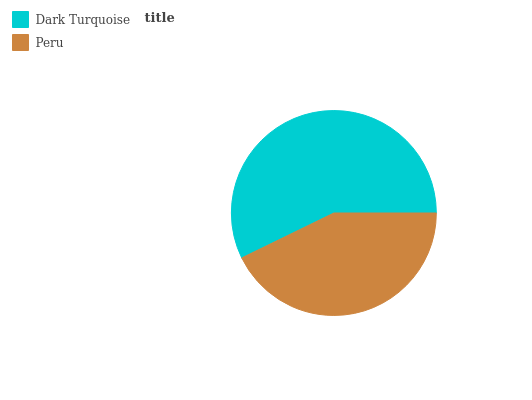Is Peru the minimum?
Answer yes or no. Yes. Is Dark Turquoise the maximum?
Answer yes or no. Yes. Is Peru the maximum?
Answer yes or no. No. Is Dark Turquoise greater than Peru?
Answer yes or no. Yes. Is Peru less than Dark Turquoise?
Answer yes or no. Yes. Is Peru greater than Dark Turquoise?
Answer yes or no. No. Is Dark Turquoise less than Peru?
Answer yes or no. No. Is Dark Turquoise the high median?
Answer yes or no. Yes. Is Peru the low median?
Answer yes or no. Yes. Is Peru the high median?
Answer yes or no. No. Is Dark Turquoise the low median?
Answer yes or no. No. 